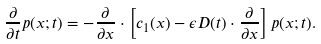Convert formula to latex. <formula><loc_0><loc_0><loc_500><loc_500>\frac { \partial } { \partial t } p ( x ; t ) = - \frac { \partial } { \partial x } \cdot \left [ c _ { 1 } ( x ) - \epsilon D ( t ) \cdot \frac { \partial } { \partial x } \right ] p ( x ; t ) .</formula> 